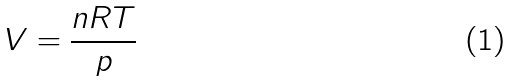Convert formula to latex. <formula><loc_0><loc_0><loc_500><loc_500>V = { \frac { n R T } { p } }</formula> 